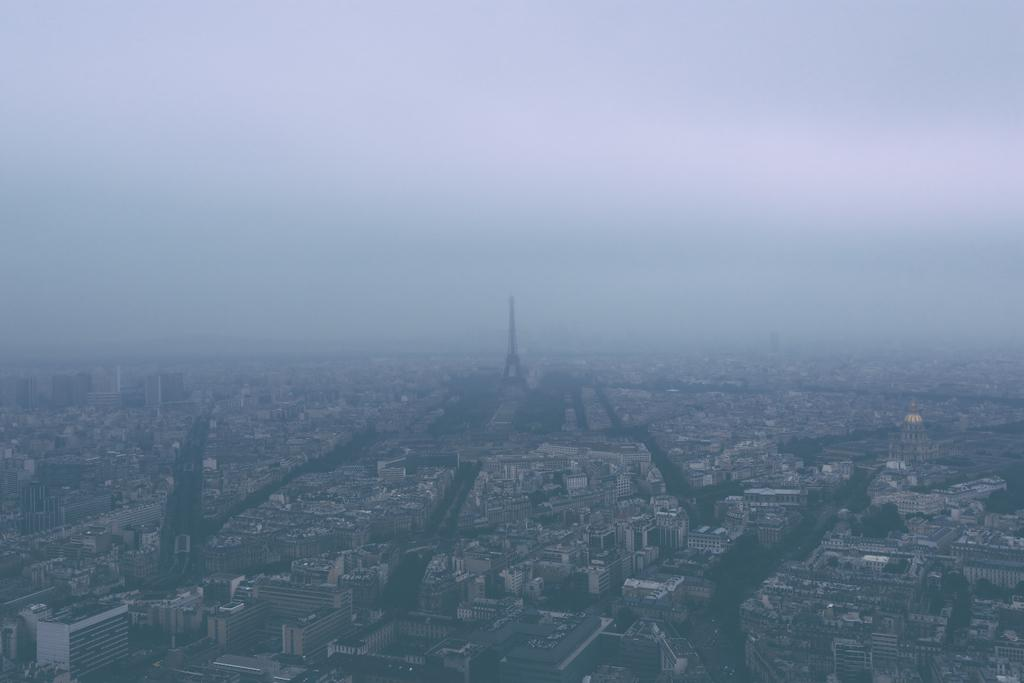What type of structures can be seen in the image? There are buildings and a tower in the image. Can you describe the background of the image? The sky is visible in the background of the image. Can you see a deer smiling in the image? There is no deer or any indication of a smile in the image. 